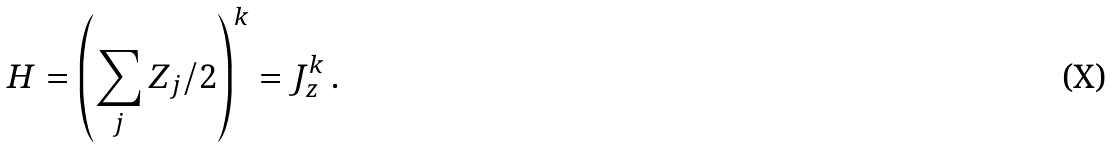<formula> <loc_0><loc_0><loc_500><loc_500>H = \left ( \sum _ { j } Z _ { j } / 2 \right ) ^ { k } = J _ { z } ^ { k } \, .</formula> 